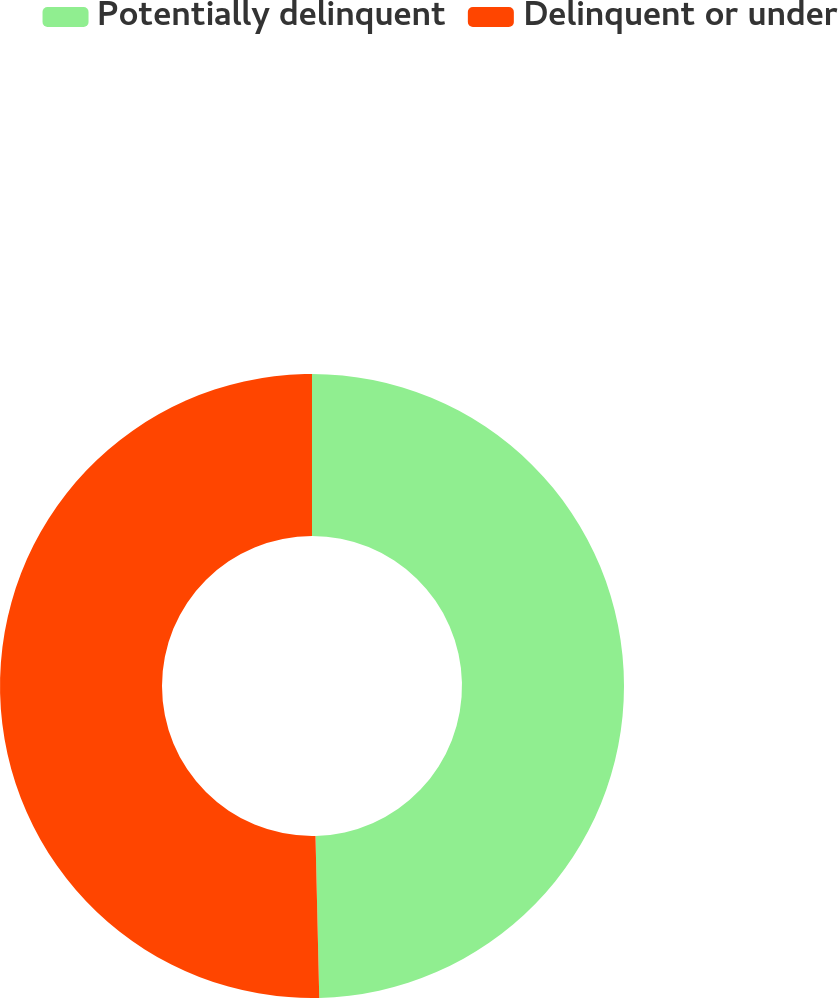Convert chart to OTSL. <chart><loc_0><loc_0><loc_500><loc_500><pie_chart><fcel>Potentially delinquent<fcel>Delinquent or under<nl><fcel>49.63%<fcel>50.37%<nl></chart> 